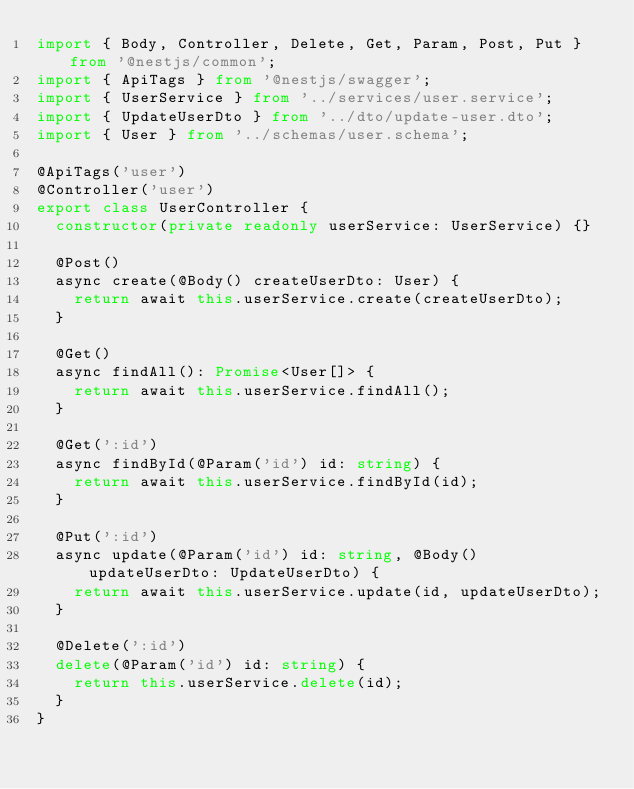<code> <loc_0><loc_0><loc_500><loc_500><_TypeScript_>import { Body, Controller, Delete, Get, Param, Post, Put } from '@nestjs/common';
import { ApiTags } from '@nestjs/swagger';
import { UserService } from '../services/user.service';
import { UpdateUserDto } from '../dto/update-user.dto';
import { User } from '../schemas/user.schema';

@ApiTags('user')
@Controller('user')
export class UserController {
  constructor(private readonly userService: UserService) {}

  @Post()
  async create(@Body() createUserDto: User) {
    return await this.userService.create(createUserDto);
  }

  @Get()
  async findAll(): Promise<User[]> {
    return await this.userService.findAll();
  }

  @Get(':id')
  async findById(@Param('id') id: string) {
    return await this.userService.findById(id);
  }

  @Put(':id')
  async update(@Param('id') id: string, @Body() updateUserDto: UpdateUserDto) {
    return await this.userService.update(id, updateUserDto);
  }

  @Delete(':id')
  delete(@Param('id') id: string) {
    return this.userService.delete(id);
  }
}
</code> 